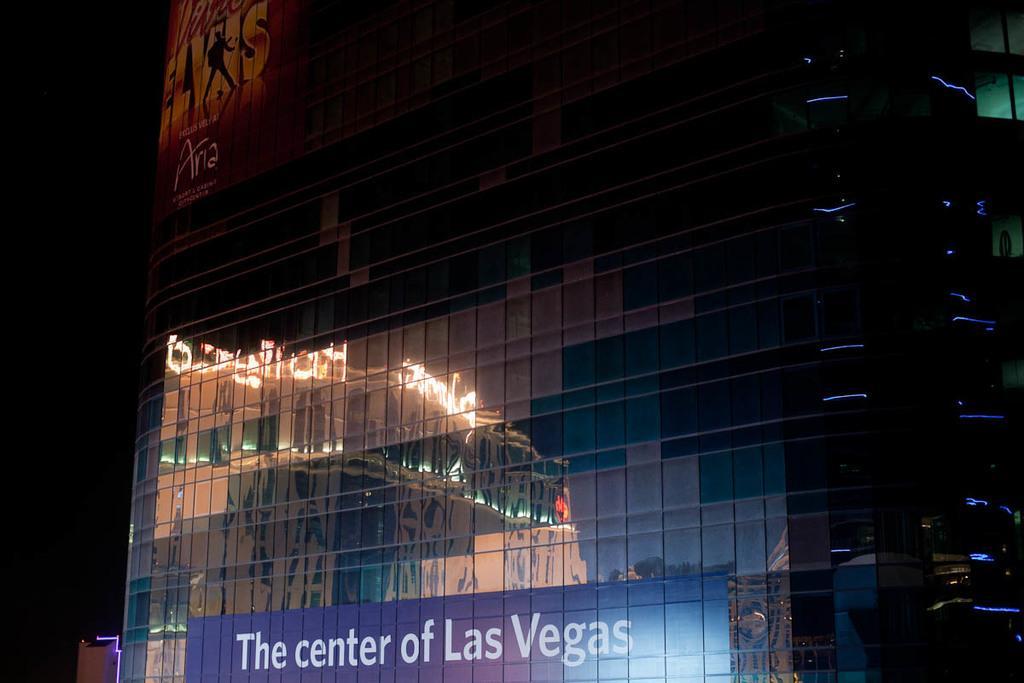Could you give a brief overview of what you see in this image? This is an image clicked in the dark. Here I can see a building with architectural glass. At the bottom of the image I can see some text on this glass. 